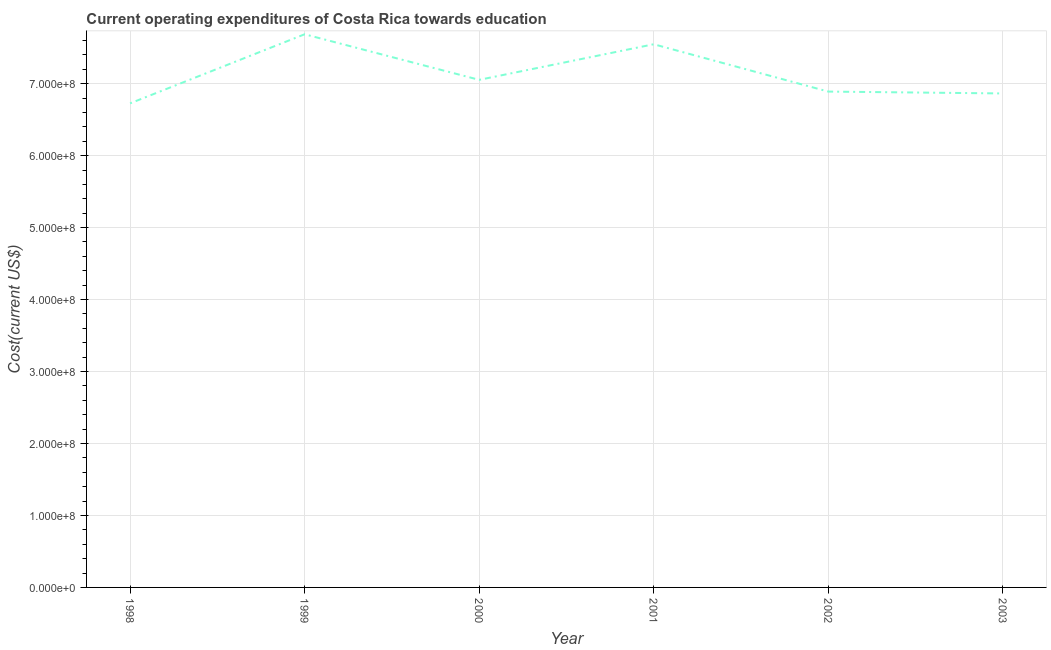What is the education expenditure in 2000?
Provide a succinct answer. 7.05e+08. Across all years, what is the maximum education expenditure?
Keep it short and to the point. 7.69e+08. Across all years, what is the minimum education expenditure?
Ensure brevity in your answer.  6.73e+08. In which year was the education expenditure maximum?
Provide a short and direct response. 1999. In which year was the education expenditure minimum?
Give a very brief answer. 1998. What is the sum of the education expenditure?
Provide a short and direct response. 4.28e+09. What is the difference between the education expenditure in 2002 and 2003?
Make the answer very short. 2.58e+06. What is the average education expenditure per year?
Your answer should be very brief. 7.13e+08. What is the median education expenditure?
Give a very brief answer. 6.97e+08. In how many years, is the education expenditure greater than 560000000 US$?
Ensure brevity in your answer.  6. What is the ratio of the education expenditure in 2001 to that in 2002?
Keep it short and to the point. 1.1. Is the difference between the education expenditure in 2000 and 2003 greater than the difference between any two years?
Keep it short and to the point. No. What is the difference between the highest and the second highest education expenditure?
Offer a very short reply. 1.39e+07. What is the difference between the highest and the lowest education expenditure?
Your answer should be compact. 9.60e+07. How many years are there in the graph?
Offer a terse response. 6. What is the difference between two consecutive major ticks on the Y-axis?
Provide a succinct answer. 1.00e+08. What is the title of the graph?
Make the answer very short. Current operating expenditures of Costa Rica towards education. What is the label or title of the X-axis?
Provide a succinct answer. Year. What is the label or title of the Y-axis?
Keep it short and to the point. Cost(current US$). What is the Cost(current US$) of 1998?
Provide a succinct answer. 6.73e+08. What is the Cost(current US$) of 1999?
Make the answer very short. 7.69e+08. What is the Cost(current US$) in 2000?
Offer a very short reply. 7.05e+08. What is the Cost(current US$) in 2001?
Offer a terse response. 7.55e+08. What is the Cost(current US$) in 2002?
Keep it short and to the point. 6.89e+08. What is the Cost(current US$) in 2003?
Ensure brevity in your answer.  6.86e+08. What is the difference between the Cost(current US$) in 1998 and 1999?
Ensure brevity in your answer.  -9.60e+07. What is the difference between the Cost(current US$) in 1998 and 2000?
Your answer should be very brief. -3.27e+07. What is the difference between the Cost(current US$) in 1998 and 2001?
Your answer should be compact. -8.21e+07. What is the difference between the Cost(current US$) in 1998 and 2002?
Offer a very short reply. -1.63e+07. What is the difference between the Cost(current US$) in 1998 and 2003?
Offer a very short reply. -1.38e+07. What is the difference between the Cost(current US$) in 1999 and 2000?
Offer a terse response. 6.33e+07. What is the difference between the Cost(current US$) in 1999 and 2001?
Offer a terse response. 1.39e+07. What is the difference between the Cost(current US$) in 1999 and 2002?
Ensure brevity in your answer.  7.96e+07. What is the difference between the Cost(current US$) in 1999 and 2003?
Your answer should be very brief. 8.22e+07. What is the difference between the Cost(current US$) in 2000 and 2001?
Offer a very short reply. -4.95e+07. What is the difference between the Cost(current US$) in 2000 and 2002?
Your answer should be very brief. 1.63e+07. What is the difference between the Cost(current US$) in 2000 and 2003?
Your answer should be very brief. 1.89e+07. What is the difference between the Cost(current US$) in 2001 and 2002?
Provide a short and direct response. 6.58e+07. What is the difference between the Cost(current US$) in 2001 and 2003?
Your response must be concise. 6.84e+07. What is the difference between the Cost(current US$) in 2002 and 2003?
Offer a very short reply. 2.58e+06. What is the ratio of the Cost(current US$) in 1998 to that in 2000?
Provide a succinct answer. 0.95. What is the ratio of the Cost(current US$) in 1998 to that in 2001?
Your answer should be very brief. 0.89. What is the ratio of the Cost(current US$) in 1998 to that in 2002?
Your answer should be very brief. 0.98. What is the ratio of the Cost(current US$) in 1999 to that in 2000?
Provide a short and direct response. 1.09. What is the ratio of the Cost(current US$) in 1999 to that in 2001?
Give a very brief answer. 1.02. What is the ratio of the Cost(current US$) in 1999 to that in 2002?
Give a very brief answer. 1.12. What is the ratio of the Cost(current US$) in 1999 to that in 2003?
Keep it short and to the point. 1.12. What is the ratio of the Cost(current US$) in 2000 to that in 2001?
Offer a very short reply. 0.93. What is the ratio of the Cost(current US$) in 2000 to that in 2003?
Ensure brevity in your answer.  1.03. What is the ratio of the Cost(current US$) in 2001 to that in 2002?
Provide a short and direct response. 1.09. 